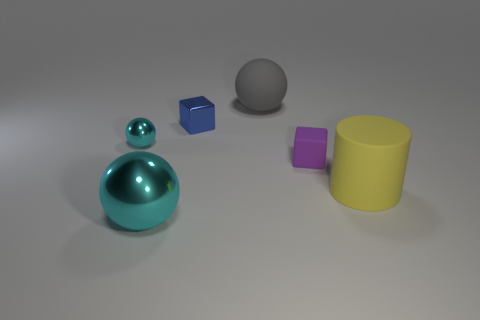What materials do the objects in the image seem to be made of? The objects seem to represent different materials. The sphere and the teardrop-shaped object have a shiny, reflective surface, suggesting they could be made of polished metal or glass. The cubes exhibit a matte finish, potentially resembling plastic or painted wood. The cylinder has a solid color with no reflections, also indicating a possibility of it being made of matte plastic or painted ceramic. 